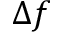Convert formula to latex. <formula><loc_0><loc_0><loc_500><loc_500>\Delta f</formula> 